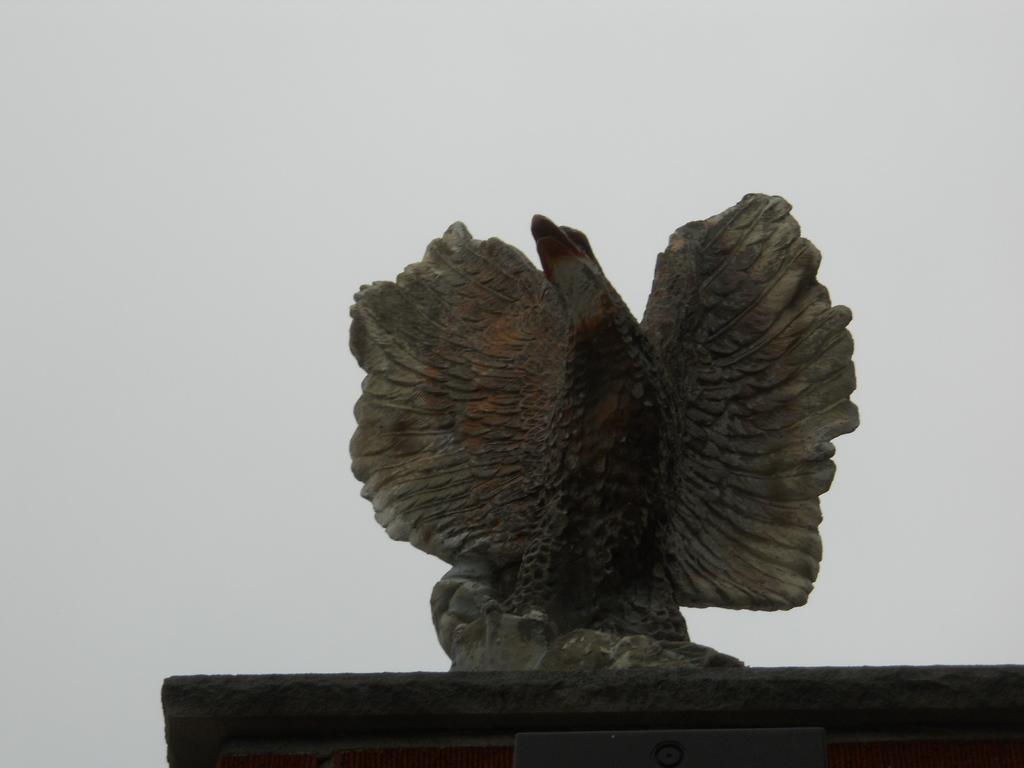What is the main subject of the image? There is a statue in the image. What is the condition of the sky in the image? The sky is cloudy in the image. Can you tell me how many crackers are placed around the statue in the image? There is no mention of crackers in the image, so we cannot determine their presence or quantity. What type of drop can be seen falling from the statue in the image? There is no drop falling from the statue in the image. Is there a cellar visible beneath the statue in the image? There is no mention of a cellar in the image, so we cannot determine its presence. 